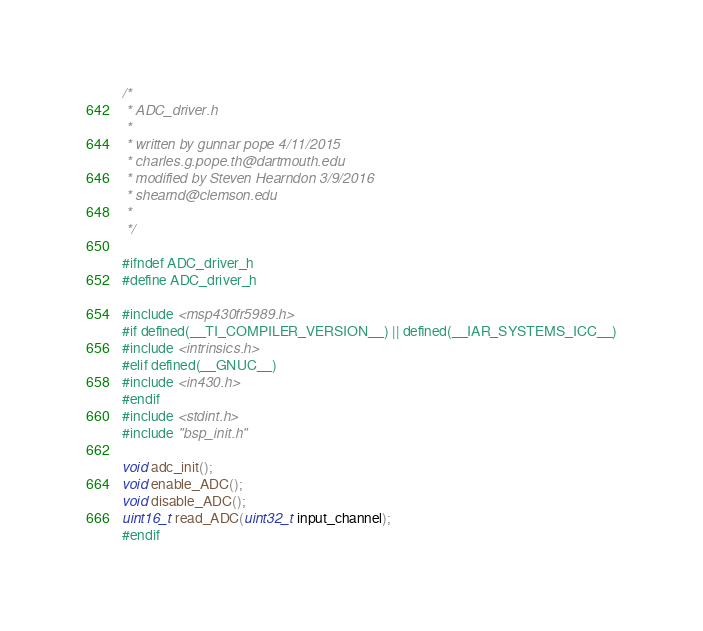Convert code to text. <code><loc_0><loc_0><loc_500><loc_500><_C_>/*
 * ADC_driver.h
 *
 * written by gunnar pope 4/11/2015
 * charles.g.pope.th@dartmouth.edu
 * modified by Steven Hearndon 3/9/2016
 * shearnd@clemson.edu
 *
 */

#ifndef ADC_driver_h
#define ADC_driver_h

#include <msp430fr5989.h>
#if defined(__TI_COMPILER_VERSION__) || defined(__IAR_SYSTEMS_ICC__)
#include <intrinsics.h>
#elif defined(__GNUC__)
#include <in430.h>
#endif
#include <stdint.h>
#include "bsp_init.h"

void adc_init();
void enable_ADC();
void disable_ADC();
uint16_t read_ADC(uint32_t input_channel);
#endif
</code> 